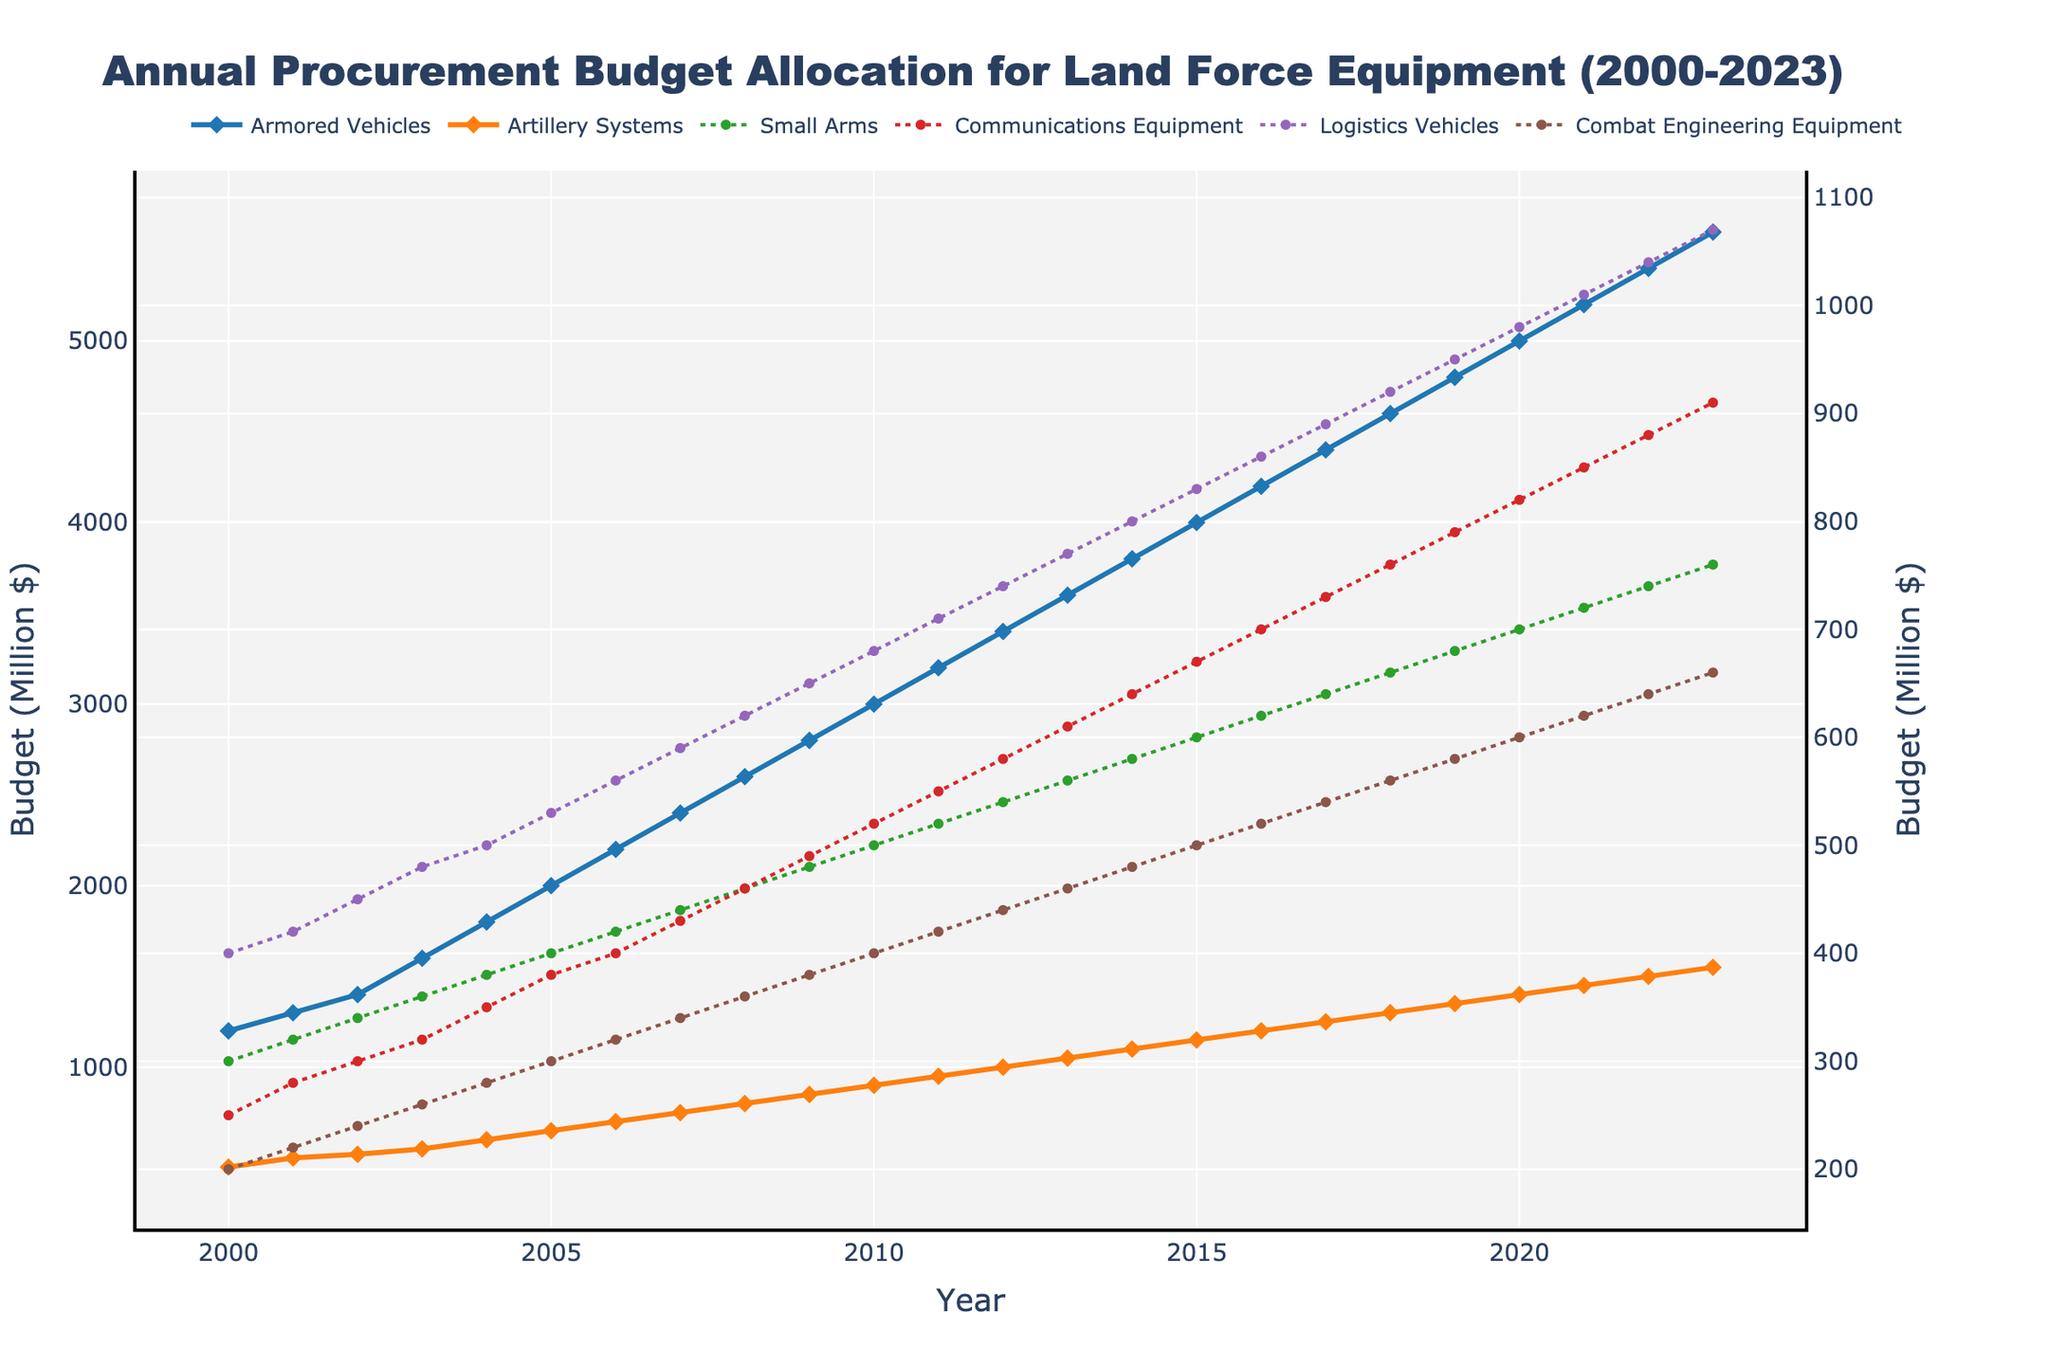What is the total budget allocation for Armored Vehicles and Artillery Systems in 2020? Sum the budget of Armored Vehicles and Artillery Systems for the year 2020: 5000 (Armored Vehicles) + 1400 (Artillery Systems) = 6400 Million $
Answer: 6400 Million $ Which equipment category saw the largest increase in budget allocation from 2000 to 2023? Subtract the 2000 budget from the 2023 budget for each category and identify the maximum difference: Armored Vehicles increased by 5600-1200=4400, Artillery Systems increased by 1550-450=1100, Small Arms increased by 760-300=460, Communications Equipment increased by 910-250=660, Logistics Vehicles increased by 1070-400=670, Combat Engineering Equipment increased by 660-200=460. The largest increase is in Armored Vehicles.
Answer: Armored Vehicles How did the budget allocation for Communications Equipment change from 2003 to 2013? Identify the budget for Communications Equipment in 2003 (320 Million $) and 2013 (610 Million $), and calculate the difference: 610 - 320 = 290 Million $.
Answer: Increased by 290 Million $ What is the average annual budget allocation for Small Arms from 2000 to 2023? Sum the annual budgets for Small Arms from 2000 to 2023 and divide by the number of years (24): (300 + 320 + 340 + ... + 760) / 24. The total sum is 15180, hence the average is 15180 / 24 = 632.5 Million $.
Answer: 632.5 Million $ Between which two consecutive years did Logistics Vehicles see the greatest budget increase? Calculate the year-to-year difference for Logistics Vehicles and identify the maximum: (420-400), (450-420), (480-450), ... , (1070-1040). The largest increase is from 1040 in 2022 to 1070 in 2023, a difference of 30 Million $.
Answer: 2022 to 2023 Which equipment category consistently ranks third in budget allocation from 2015 to 2023? Examine the yearly budget figures from 2015 to 2023 and identify the category that is consistently in the third position: Armored Vehicles, Artillery Systems, and then Communications Equipment.
Answer: Communications Equipment Which category saw the smallest increase in budget allocation over the entire period? Subtract 2000 allocations from 2023 allocations for each category and identify the smallest difference: Small Arms increased by 760-300 = 460 Million $.
Answer: Small Arms In which year did Combat Engineering Equipment budget pass the 500 Million $ mark? Examine the yearly budget data for Combat Engineering Equipment to determine the first year the budget is above 500 Million $: 2016 with 520 Million $.
Answer: 2016 What is the difference in total budget allocation between the highest and lowest funded categories in 2023? Identify the 2023 budgets for the highest(Armored Vehicles-5600 Million $) and lowest(Small Arms-760 Million $) funded categories and calculate the difference: 5600 - 760 = 4840 Million $.
Answer: 4840 Million $ Is there any year where Artillery Systems had a higher budget than Armored Vehicles? Compare the annual budget values for Armored Vehicles and Artillery Systems: Armored Vehicles always have a higher budget than Artillery Systems.
Answer: No 